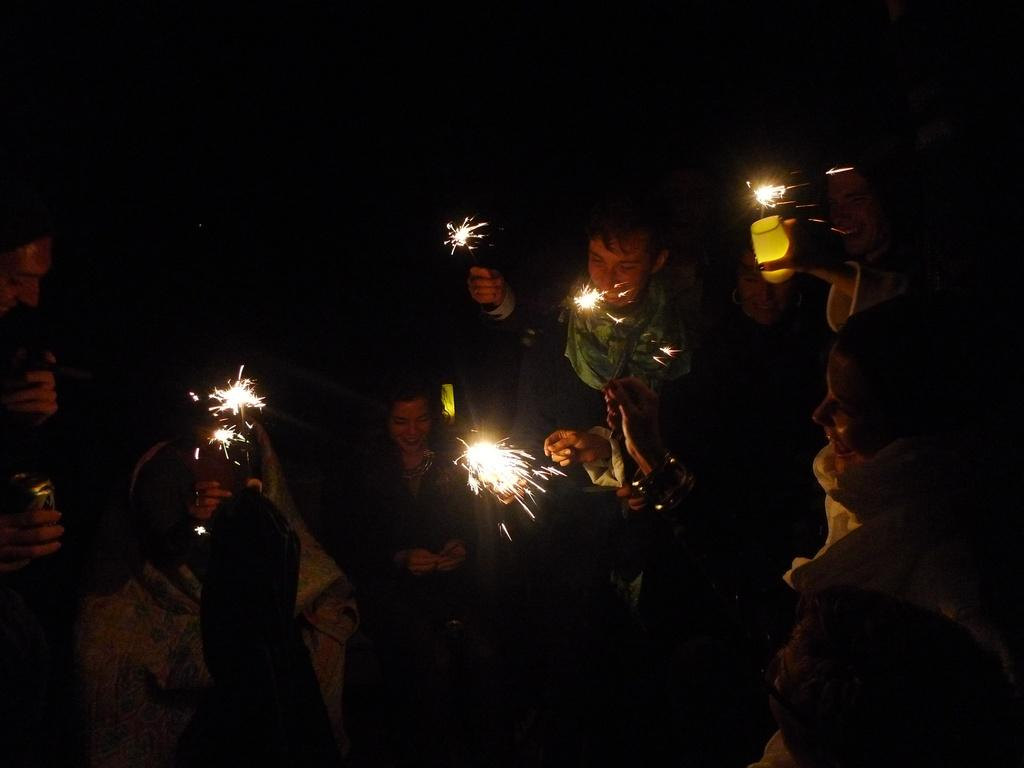Who is present in the image? There are children in the image. What are the children doing in the image? The children are lighting crackers. What is the acoustics like in the image? The provided facts do not mention anything about the acoustics in the image, so it cannot be determined from the image. 